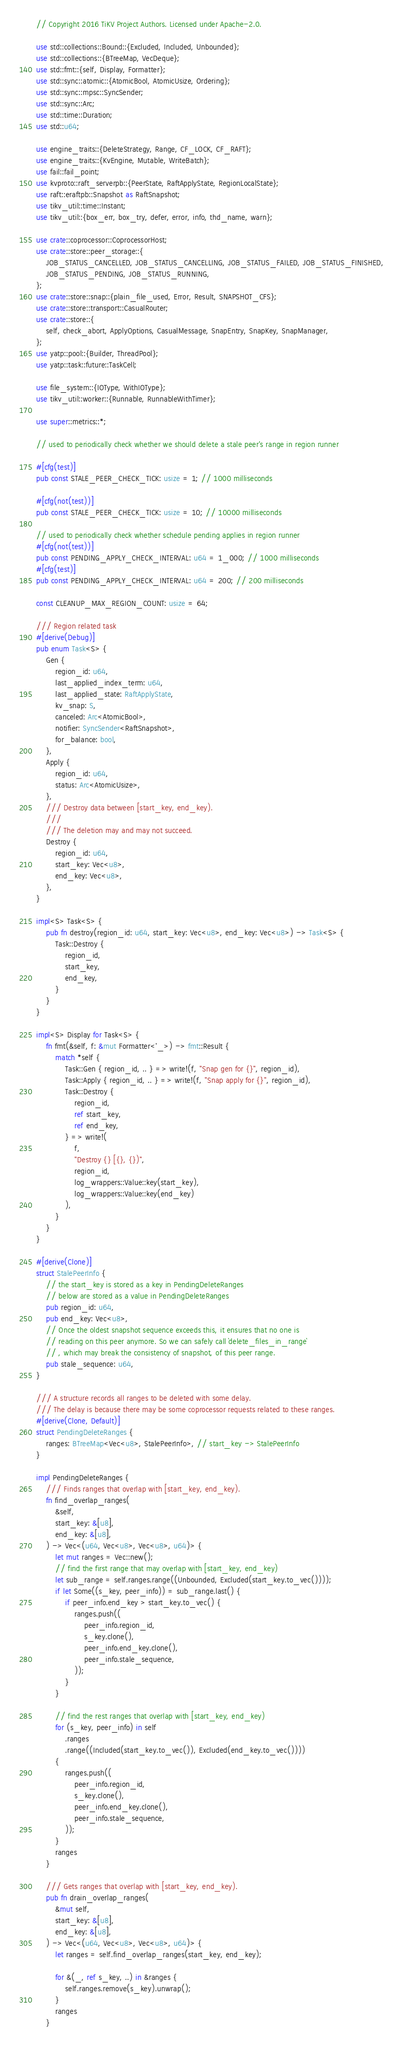<code> <loc_0><loc_0><loc_500><loc_500><_Rust_>// Copyright 2016 TiKV Project Authors. Licensed under Apache-2.0.

use std::collections::Bound::{Excluded, Included, Unbounded};
use std::collections::{BTreeMap, VecDeque};
use std::fmt::{self, Display, Formatter};
use std::sync::atomic::{AtomicBool, AtomicUsize, Ordering};
use std::sync::mpsc::SyncSender;
use std::sync::Arc;
use std::time::Duration;
use std::u64;

use engine_traits::{DeleteStrategy, Range, CF_LOCK, CF_RAFT};
use engine_traits::{KvEngine, Mutable, WriteBatch};
use fail::fail_point;
use kvproto::raft_serverpb::{PeerState, RaftApplyState, RegionLocalState};
use raft::eraftpb::Snapshot as RaftSnapshot;
use tikv_util::time::Instant;
use tikv_util::{box_err, box_try, defer, error, info, thd_name, warn};

use crate::coprocessor::CoprocessorHost;
use crate::store::peer_storage::{
    JOB_STATUS_CANCELLED, JOB_STATUS_CANCELLING, JOB_STATUS_FAILED, JOB_STATUS_FINISHED,
    JOB_STATUS_PENDING, JOB_STATUS_RUNNING,
};
use crate::store::snap::{plain_file_used, Error, Result, SNAPSHOT_CFS};
use crate::store::transport::CasualRouter;
use crate::store::{
    self, check_abort, ApplyOptions, CasualMessage, SnapEntry, SnapKey, SnapManager,
};
use yatp::pool::{Builder, ThreadPool};
use yatp::task::future::TaskCell;

use file_system::{IOType, WithIOType};
use tikv_util::worker::{Runnable, RunnableWithTimer};

use super::metrics::*;

// used to periodically check whether we should delete a stale peer's range in region runner

#[cfg(test)]
pub const STALE_PEER_CHECK_TICK: usize = 1; // 1000 milliseconds

#[cfg(not(test))]
pub const STALE_PEER_CHECK_TICK: usize = 10; // 10000 milliseconds

// used to periodically check whether schedule pending applies in region runner
#[cfg(not(test))]
pub const PENDING_APPLY_CHECK_INTERVAL: u64 = 1_000; // 1000 milliseconds
#[cfg(test)]
pub const PENDING_APPLY_CHECK_INTERVAL: u64 = 200; // 200 milliseconds

const CLEANUP_MAX_REGION_COUNT: usize = 64;

/// Region related task
#[derive(Debug)]
pub enum Task<S> {
    Gen {
        region_id: u64,
        last_applied_index_term: u64,
        last_applied_state: RaftApplyState,
        kv_snap: S,
        canceled: Arc<AtomicBool>,
        notifier: SyncSender<RaftSnapshot>,
        for_balance: bool,
    },
    Apply {
        region_id: u64,
        status: Arc<AtomicUsize>,
    },
    /// Destroy data between [start_key, end_key).
    ///
    /// The deletion may and may not succeed.
    Destroy {
        region_id: u64,
        start_key: Vec<u8>,
        end_key: Vec<u8>,
    },
}

impl<S> Task<S> {
    pub fn destroy(region_id: u64, start_key: Vec<u8>, end_key: Vec<u8>) -> Task<S> {
        Task::Destroy {
            region_id,
            start_key,
            end_key,
        }
    }
}

impl<S> Display for Task<S> {
    fn fmt(&self, f: &mut Formatter<'_>) -> fmt::Result {
        match *self {
            Task::Gen { region_id, .. } => write!(f, "Snap gen for {}", region_id),
            Task::Apply { region_id, .. } => write!(f, "Snap apply for {}", region_id),
            Task::Destroy {
                region_id,
                ref start_key,
                ref end_key,
            } => write!(
                f,
                "Destroy {} [{}, {})",
                region_id,
                log_wrappers::Value::key(start_key),
                log_wrappers::Value::key(end_key)
            ),
        }
    }
}

#[derive(Clone)]
struct StalePeerInfo {
    // the start_key is stored as a key in PendingDeleteRanges
    // below are stored as a value in PendingDeleteRanges
    pub region_id: u64,
    pub end_key: Vec<u8>,
    // Once the oldest snapshot sequence exceeds this, it ensures that no one is
    // reading on this peer anymore. So we can safely call `delete_files_in_range`
    // , which may break the consistency of snapshot, of this peer range.
    pub stale_sequence: u64,
}

/// A structure records all ranges to be deleted with some delay.
/// The delay is because there may be some coprocessor requests related to these ranges.
#[derive(Clone, Default)]
struct PendingDeleteRanges {
    ranges: BTreeMap<Vec<u8>, StalePeerInfo>, // start_key -> StalePeerInfo
}

impl PendingDeleteRanges {
    /// Finds ranges that overlap with [start_key, end_key).
    fn find_overlap_ranges(
        &self,
        start_key: &[u8],
        end_key: &[u8],
    ) -> Vec<(u64, Vec<u8>, Vec<u8>, u64)> {
        let mut ranges = Vec::new();
        // find the first range that may overlap with [start_key, end_key)
        let sub_range = self.ranges.range((Unbounded, Excluded(start_key.to_vec())));
        if let Some((s_key, peer_info)) = sub_range.last() {
            if peer_info.end_key > start_key.to_vec() {
                ranges.push((
                    peer_info.region_id,
                    s_key.clone(),
                    peer_info.end_key.clone(),
                    peer_info.stale_sequence,
                ));
            }
        }

        // find the rest ranges that overlap with [start_key, end_key)
        for (s_key, peer_info) in self
            .ranges
            .range((Included(start_key.to_vec()), Excluded(end_key.to_vec())))
        {
            ranges.push((
                peer_info.region_id,
                s_key.clone(),
                peer_info.end_key.clone(),
                peer_info.stale_sequence,
            ));
        }
        ranges
    }

    /// Gets ranges that overlap with [start_key, end_key).
    pub fn drain_overlap_ranges(
        &mut self,
        start_key: &[u8],
        end_key: &[u8],
    ) -> Vec<(u64, Vec<u8>, Vec<u8>, u64)> {
        let ranges = self.find_overlap_ranges(start_key, end_key);

        for &(_, ref s_key, ..) in &ranges {
            self.ranges.remove(s_key).unwrap();
        }
        ranges
    }
</code> 